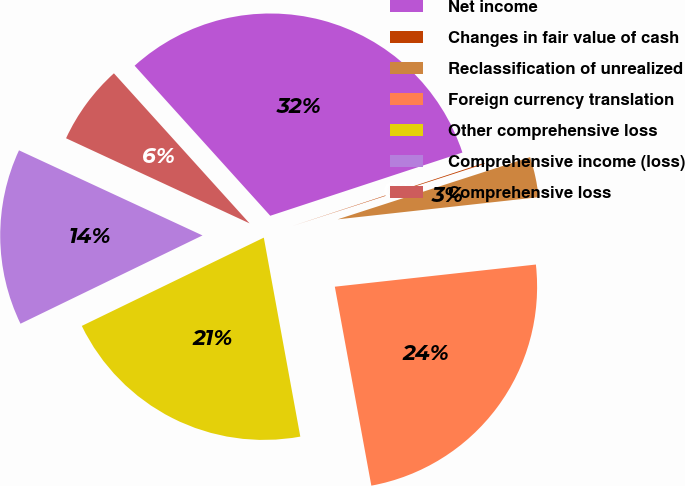<chart> <loc_0><loc_0><loc_500><loc_500><pie_chart><fcel>Net income<fcel>Changes in fair value of cash<fcel>Reclassification of unrealized<fcel>Foreign currency translation<fcel>Other comprehensive loss<fcel>Comprehensive income (loss)<fcel>Comprehensive loss<nl><fcel>31.64%<fcel>0.08%<fcel>3.23%<fcel>23.86%<fcel>20.7%<fcel>14.1%<fcel>6.39%<nl></chart> 